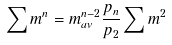Convert formula to latex. <formula><loc_0><loc_0><loc_500><loc_500>\sum m ^ { n } = m _ { a v } ^ { n - 2 } \frac { p _ { n } } { p _ { 2 } } \sum m ^ { 2 }</formula> 